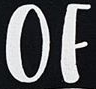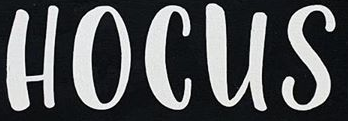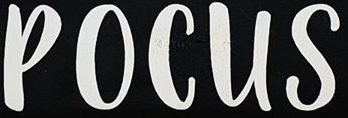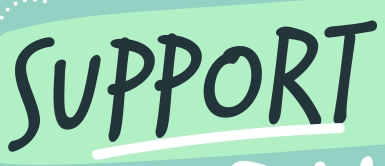What text is displayed in these images sequentially, separated by a semicolon? OF; HOCUS; POCUS; SUPPORT 